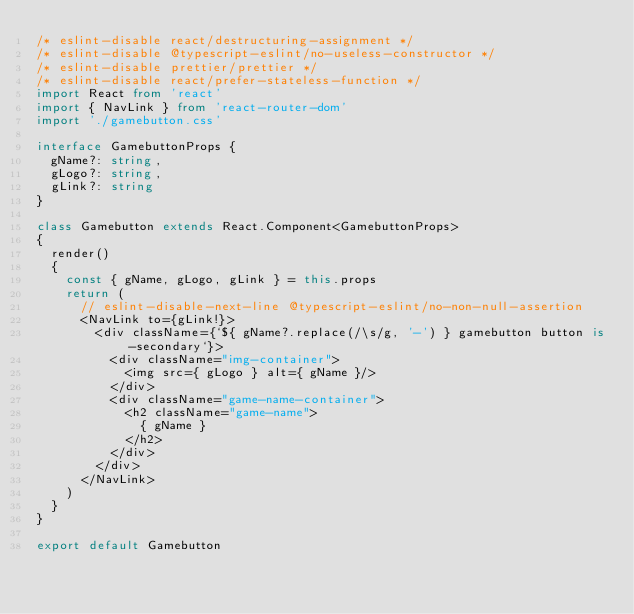<code> <loc_0><loc_0><loc_500><loc_500><_TypeScript_>/* eslint-disable react/destructuring-assignment */
/* eslint-disable @typescript-eslint/no-useless-constructor */
/* eslint-disable prettier/prettier */
/* eslint-disable react/prefer-stateless-function */
import React from 'react'
import { NavLink } from 'react-router-dom'
import './gamebutton.css'

interface GamebuttonProps {
  gName?: string,
  gLogo?: string,
  gLink?: string
}

class Gamebutton extends React.Component<GamebuttonProps>
{
  render()
  {
    const { gName, gLogo, gLink } = this.props
    return (
      // eslint-disable-next-line @typescript-eslint/no-non-null-assertion
      <NavLink to={gLink!}>
        <div className={`${ gName?.replace(/\s/g, '-') } gamebutton button is-secondary`}>
          <div className="img-container">
            <img src={ gLogo } alt={ gName }/>
          </div>
          <div className="game-name-container">
            <h2 className="game-name">
              { gName }
            </h2>
          </div>
        </div>
      </NavLink>
    )
  }
}

export default Gamebutton
</code> 